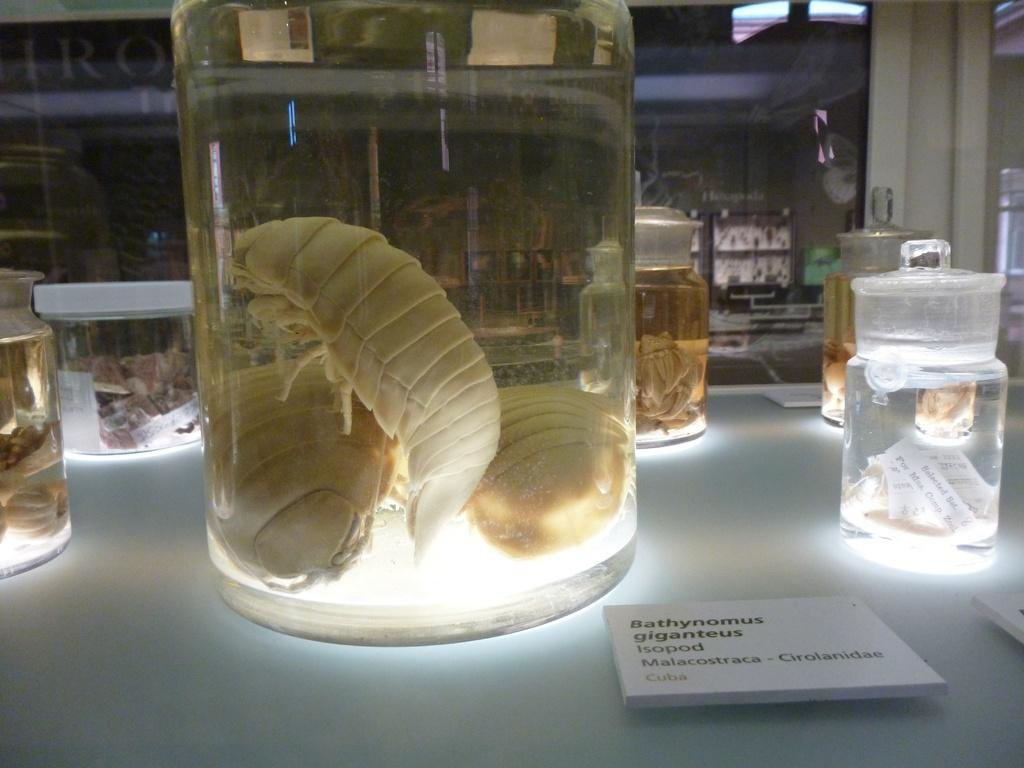<image>
Offer a succinct explanation of the picture presented. Various preserved specimens, including the isopod Bathynomus Giganteus, are displayed in lighted glass jars. 